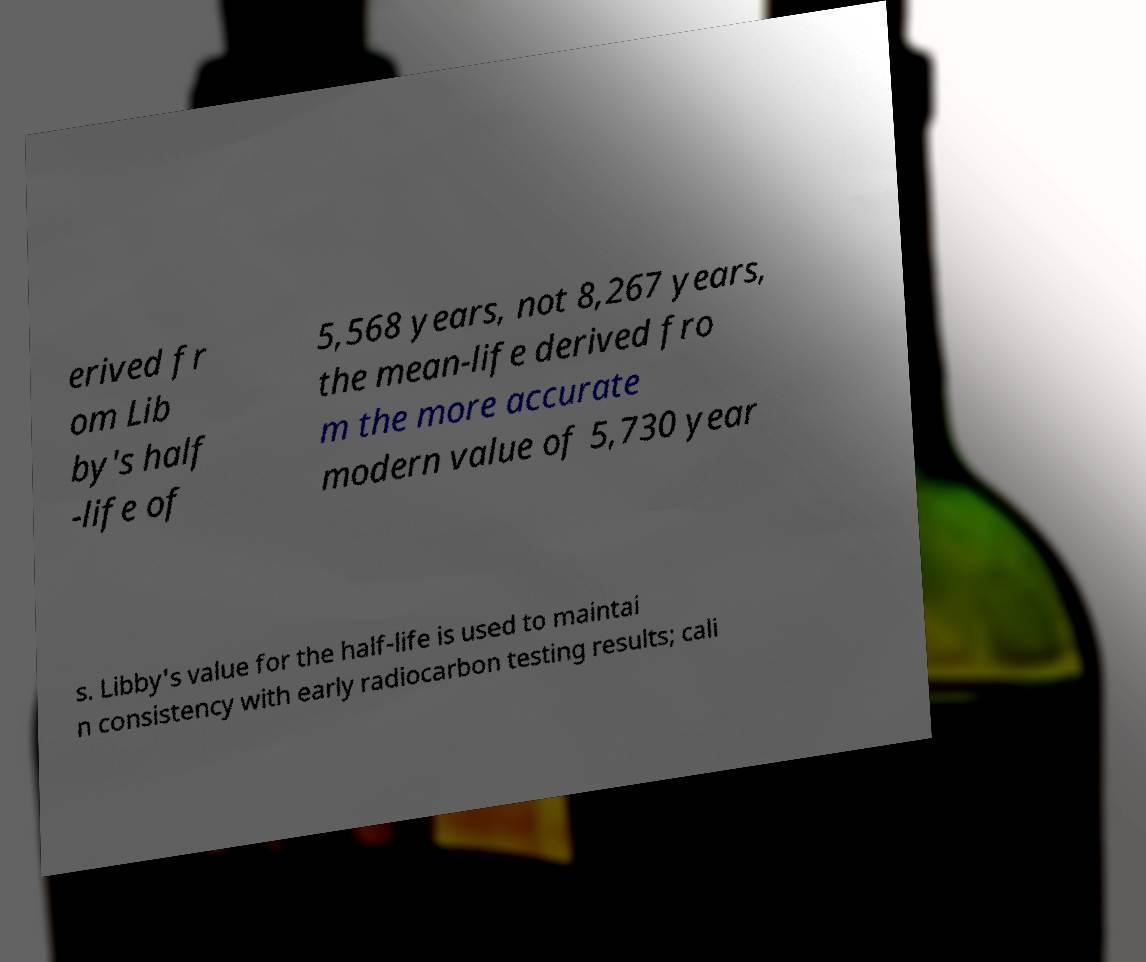Could you extract and type out the text from this image? erived fr om Lib by's half -life of 5,568 years, not 8,267 years, the mean-life derived fro m the more accurate modern value of 5,730 year s. Libby's value for the half-life is used to maintai n consistency with early radiocarbon testing results; cali 